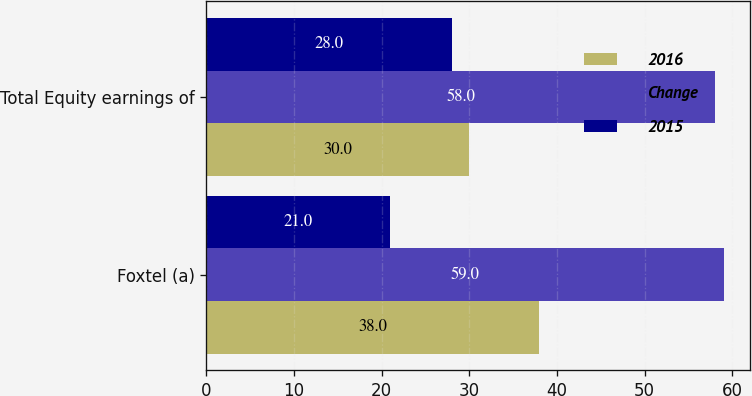<chart> <loc_0><loc_0><loc_500><loc_500><stacked_bar_chart><ecel><fcel>Foxtel (a)<fcel>Total Equity earnings of<nl><fcel>2016<fcel>38<fcel>30<nl><fcel>Change<fcel>59<fcel>58<nl><fcel>2015<fcel>21<fcel>28<nl></chart> 